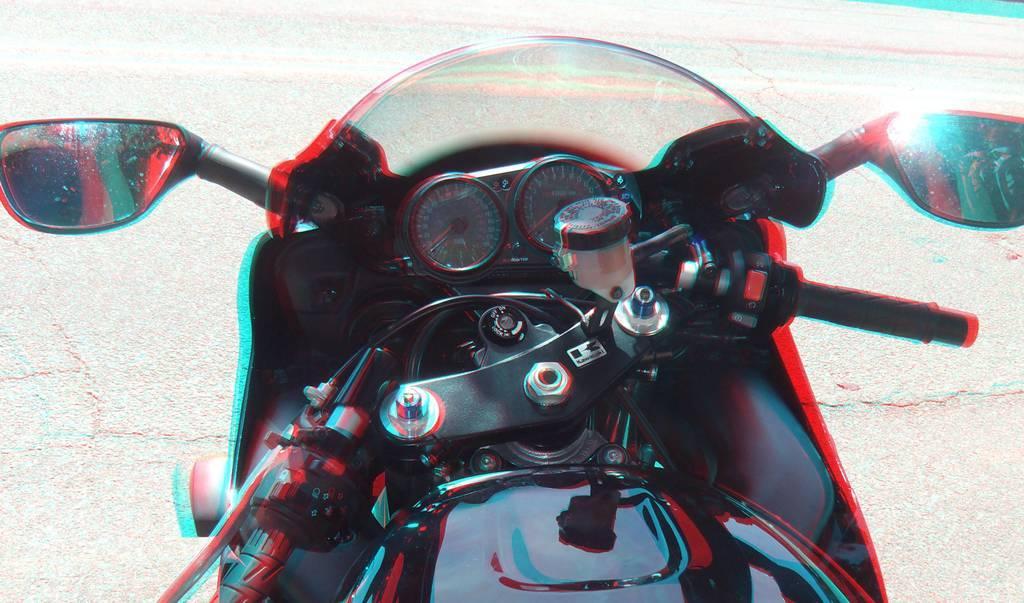Describe this image in one or two sentences. In this picture I can see a bike in front and I can see the road and I see that this image is a bit edited. 